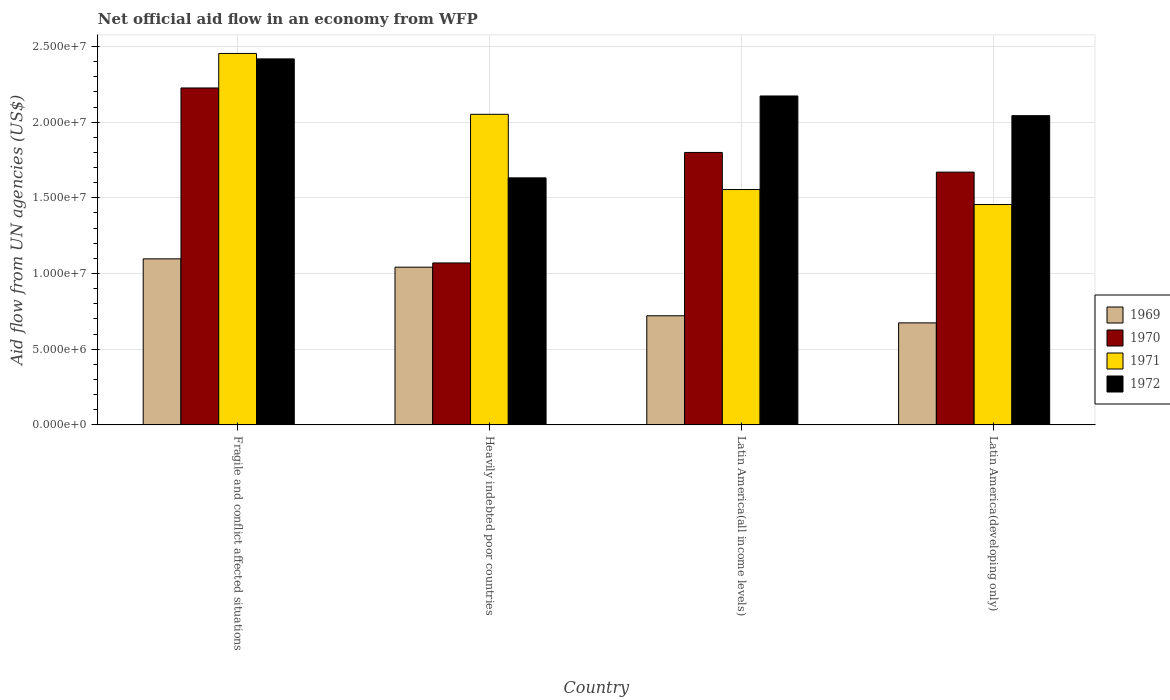How many groups of bars are there?
Keep it short and to the point. 4. How many bars are there on the 2nd tick from the left?
Your response must be concise. 4. How many bars are there on the 3rd tick from the right?
Provide a short and direct response. 4. What is the label of the 3rd group of bars from the left?
Give a very brief answer. Latin America(all income levels). What is the net official aid flow in 1969 in Latin America(all income levels)?
Make the answer very short. 7.21e+06. Across all countries, what is the maximum net official aid flow in 1972?
Provide a succinct answer. 2.42e+07. Across all countries, what is the minimum net official aid flow in 1969?
Keep it short and to the point. 6.74e+06. In which country was the net official aid flow in 1972 maximum?
Keep it short and to the point. Fragile and conflict affected situations. In which country was the net official aid flow in 1971 minimum?
Your answer should be very brief. Latin America(developing only). What is the total net official aid flow in 1972 in the graph?
Keep it short and to the point. 8.27e+07. What is the difference between the net official aid flow in 1969 in Latin America(developing only) and the net official aid flow in 1972 in Heavily indebted poor countries?
Provide a short and direct response. -9.58e+06. What is the average net official aid flow in 1971 per country?
Provide a succinct answer. 1.88e+07. What is the difference between the net official aid flow of/in 1970 and net official aid flow of/in 1971 in Latin America(all income levels)?
Your response must be concise. 2.45e+06. What is the ratio of the net official aid flow in 1969 in Heavily indebted poor countries to that in Latin America(developing only)?
Your response must be concise. 1.55. Is the net official aid flow in 1970 in Heavily indebted poor countries less than that in Latin America(developing only)?
Make the answer very short. Yes. What is the difference between the highest and the second highest net official aid flow in 1972?
Offer a very short reply. 3.75e+06. What is the difference between the highest and the lowest net official aid flow in 1970?
Provide a succinct answer. 1.16e+07. Is it the case that in every country, the sum of the net official aid flow in 1969 and net official aid flow in 1972 is greater than the sum of net official aid flow in 1971 and net official aid flow in 1970?
Keep it short and to the point. No. Is it the case that in every country, the sum of the net official aid flow in 1969 and net official aid flow in 1971 is greater than the net official aid flow in 1972?
Your response must be concise. Yes. How many bars are there?
Ensure brevity in your answer.  16. Are all the bars in the graph horizontal?
Offer a terse response. No. How many countries are there in the graph?
Your answer should be compact. 4. Are the values on the major ticks of Y-axis written in scientific E-notation?
Your answer should be very brief. Yes. Does the graph contain grids?
Your answer should be very brief. Yes. How are the legend labels stacked?
Provide a short and direct response. Vertical. What is the title of the graph?
Offer a terse response. Net official aid flow in an economy from WFP. Does "1972" appear as one of the legend labels in the graph?
Provide a short and direct response. Yes. What is the label or title of the Y-axis?
Offer a terse response. Aid flow from UN agencies (US$). What is the Aid flow from UN agencies (US$) in 1969 in Fragile and conflict affected situations?
Your answer should be very brief. 1.10e+07. What is the Aid flow from UN agencies (US$) of 1970 in Fragile and conflict affected situations?
Make the answer very short. 2.23e+07. What is the Aid flow from UN agencies (US$) in 1971 in Fragile and conflict affected situations?
Give a very brief answer. 2.45e+07. What is the Aid flow from UN agencies (US$) of 1972 in Fragile and conflict affected situations?
Your answer should be compact. 2.42e+07. What is the Aid flow from UN agencies (US$) of 1969 in Heavily indebted poor countries?
Keep it short and to the point. 1.04e+07. What is the Aid flow from UN agencies (US$) in 1970 in Heavily indebted poor countries?
Make the answer very short. 1.07e+07. What is the Aid flow from UN agencies (US$) of 1971 in Heavily indebted poor countries?
Offer a terse response. 2.05e+07. What is the Aid flow from UN agencies (US$) of 1972 in Heavily indebted poor countries?
Your response must be concise. 1.63e+07. What is the Aid flow from UN agencies (US$) of 1969 in Latin America(all income levels)?
Give a very brief answer. 7.21e+06. What is the Aid flow from UN agencies (US$) in 1970 in Latin America(all income levels)?
Offer a terse response. 1.80e+07. What is the Aid flow from UN agencies (US$) of 1971 in Latin America(all income levels)?
Make the answer very short. 1.56e+07. What is the Aid flow from UN agencies (US$) of 1972 in Latin America(all income levels)?
Your answer should be compact. 2.17e+07. What is the Aid flow from UN agencies (US$) of 1969 in Latin America(developing only)?
Your response must be concise. 6.74e+06. What is the Aid flow from UN agencies (US$) in 1970 in Latin America(developing only)?
Your answer should be compact. 1.67e+07. What is the Aid flow from UN agencies (US$) of 1971 in Latin America(developing only)?
Keep it short and to the point. 1.46e+07. What is the Aid flow from UN agencies (US$) in 1972 in Latin America(developing only)?
Your response must be concise. 2.04e+07. Across all countries, what is the maximum Aid flow from UN agencies (US$) of 1969?
Provide a succinct answer. 1.10e+07. Across all countries, what is the maximum Aid flow from UN agencies (US$) of 1970?
Keep it short and to the point. 2.23e+07. Across all countries, what is the maximum Aid flow from UN agencies (US$) of 1971?
Give a very brief answer. 2.45e+07. Across all countries, what is the maximum Aid flow from UN agencies (US$) of 1972?
Provide a succinct answer. 2.42e+07. Across all countries, what is the minimum Aid flow from UN agencies (US$) in 1969?
Ensure brevity in your answer.  6.74e+06. Across all countries, what is the minimum Aid flow from UN agencies (US$) in 1970?
Give a very brief answer. 1.07e+07. Across all countries, what is the minimum Aid flow from UN agencies (US$) of 1971?
Keep it short and to the point. 1.46e+07. Across all countries, what is the minimum Aid flow from UN agencies (US$) in 1972?
Provide a succinct answer. 1.63e+07. What is the total Aid flow from UN agencies (US$) in 1969 in the graph?
Keep it short and to the point. 3.53e+07. What is the total Aid flow from UN agencies (US$) in 1970 in the graph?
Give a very brief answer. 6.77e+07. What is the total Aid flow from UN agencies (US$) of 1971 in the graph?
Give a very brief answer. 7.52e+07. What is the total Aid flow from UN agencies (US$) in 1972 in the graph?
Your answer should be very brief. 8.27e+07. What is the difference between the Aid flow from UN agencies (US$) of 1970 in Fragile and conflict affected situations and that in Heavily indebted poor countries?
Ensure brevity in your answer.  1.16e+07. What is the difference between the Aid flow from UN agencies (US$) of 1971 in Fragile and conflict affected situations and that in Heavily indebted poor countries?
Provide a succinct answer. 4.02e+06. What is the difference between the Aid flow from UN agencies (US$) in 1972 in Fragile and conflict affected situations and that in Heavily indebted poor countries?
Your response must be concise. 7.86e+06. What is the difference between the Aid flow from UN agencies (US$) in 1969 in Fragile and conflict affected situations and that in Latin America(all income levels)?
Your answer should be compact. 3.76e+06. What is the difference between the Aid flow from UN agencies (US$) in 1970 in Fragile and conflict affected situations and that in Latin America(all income levels)?
Provide a succinct answer. 4.26e+06. What is the difference between the Aid flow from UN agencies (US$) of 1971 in Fragile and conflict affected situations and that in Latin America(all income levels)?
Your answer should be very brief. 8.99e+06. What is the difference between the Aid flow from UN agencies (US$) of 1972 in Fragile and conflict affected situations and that in Latin America(all income levels)?
Ensure brevity in your answer.  2.45e+06. What is the difference between the Aid flow from UN agencies (US$) of 1969 in Fragile and conflict affected situations and that in Latin America(developing only)?
Provide a short and direct response. 4.23e+06. What is the difference between the Aid flow from UN agencies (US$) in 1970 in Fragile and conflict affected situations and that in Latin America(developing only)?
Your answer should be compact. 5.56e+06. What is the difference between the Aid flow from UN agencies (US$) in 1971 in Fragile and conflict affected situations and that in Latin America(developing only)?
Make the answer very short. 9.98e+06. What is the difference between the Aid flow from UN agencies (US$) of 1972 in Fragile and conflict affected situations and that in Latin America(developing only)?
Your response must be concise. 3.75e+06. What is the difference between the Aid flow from UN agencies (US$) in 1969 in Heavily indebted poor countries and that in Latin America(all income levels)?
Ensure brevity in your answer.  3.21e+06. What is the difference between the Aid flow from UN agencies (US$) in 1970 in Heavily indebted poor countries and that in Latin America(all income levels)?
Your answer should be compact. -7.30e+06. What is the difference between the Aid flow from UN agencies (US$) in 1971 in Heavily indebted poor countries and that in Latin America(all income levels)?
Provide a succinct answer. 4.97e+06. What is the difference between the Aid flow from UN agencies (US$) of 1972 in Heavily indebted poor countries and that in Latin America(all income levels)?
Offer a terse response. -5.41e+06. What is the difference between the Aid flow from UN agencies (US$) of 1969 in Heavily indebted poor countries and that in Latin America(developing only)?
Provide a short and direct response. 3.68e+06. What is the difference between the Aid flow from UN agencies (US$) of 1970 in Heavily indebted poor countries and that in Latin America(developing only)?
Ensure brevity in your answer.  -6.00e+06. What is the difference between the Aid flow from UN agencies (US$) of 1971 in Heavily indebted poor countries and that in Latin America(developing only)?
Ensure brevity in your answer.  5.96e+06. What is the difference between the Aid flow from UN agencies (US$) in 1972 in Heavily indebted poor countries and that in Latin America(developing only)?
Offer a very short reply. -4.11e+06. What is the difference between the Aid flow from UN agencies (US$) of 1970 in Latin America(all income levels) and that in Latin America(developing only)?
Give a very brief answer. 1.30e+06. What is the difference between the Aid flow from UN agencies (US$) in 1971 in Latin America(all income levels) and that in Latin America(developing only)?
Your answer should be compact. 9.90e+05. What is the difference between the Aid flow from UN agencies (US$) in 1972 in Latin America(all income levels) and that in Latin America(developing only)?
Give a very brief answer. 1.30e+06. What is the difference between the Aid flow from UN agencies (US$) of 1969 in Fragile and conflict affected situations and the Aid flow from UN agencies (US$) of 1971 in Heavily indebted poor countries?
Give a very brief answer. -9.55e+06. What is the difference between the Aid flow from UN agencies (US$) of 1969 in Fragile and conflict affected situations and the Aid flow from UN agencies (US$) of 1972 in Heavily indebted poor countries?
Keep it short and to the point. -5.35e+06. What is the difference between the Aid flow from UN agencies (US$) of 1970 in Fragile and conflict affected situations and the Aid flow from UN agencies (US$) of 1971 in Heavily indebted poor countries?
Ensure brevity in your answer.  1.74e+06. What is the difference between the Aid flow from UN agencies (US$) of 1970 in Fragile and conflict affected situations and the Aid flow from UN agencies (US$) of 1972 in Heavily indebted poor countries?
Provide a short and direct response. 5.94e+06. What is the difference between the Aid flow from UN agencies (US$) of 1971 in Fragile and conflict affected situations and the Aid flow from UN agencies (US$) of 1972 in Heavily indebted poor countries?
Your answer should be compact. 8.22e+06. What is the difference between the Aid flow from UN agencies (US$) of 1969 in Fragile and conflict affected situations and the Aid flow from UN agencies (US$) of 1970 in Latin America(all income levels)?
Provide a succinct answer. -7.03e+06. What is the difference between the Aid flow from UN agencies (US$) in 1969 in Fragile and conflict affected situations and the Aid flow from UN agencies (US$) in 1971 in Latin America(all income levels)?
Your response must be concise. -4.58e+06. What is the difference between the Aid flow from UN agencies (US$) of 1969 in Fragile and conflict affected situations and the Aid flow from UN agencies (US$) of 1972 in Latin America(all income levels)?
Give a very brief answer. -1.08e+07. What is the difference between the Aid flow from UN agencies (US$) of 1970 in Fragile and conflict affected situations and the Aid flow from UN agencies (US$) of 1971 in Latin America(all income levels)?
Your answer should be compact. 6.71e+06. What is the difference between the Aid flow from UN agencies (US$) of 1970 in Fragile and conflict affected situations and the Aid flow from UN agencies (US$) of 1972 in Latin America(all income levels)?
Provide a short and direct response. 5.30e+05. What is the difference between the Aid flow from UN agencies (US$) of 1971 in Fragile and conflict affected situations and the Aid flow from UN agencies (US$) of 1972 in Latin America(all income levels)?
Provide a succinct answer. 2.81e+06. What is the difference between the Aid flow from UN agencies (US$) of 1969 in Fragile and conflict affected situations and the Aid flow from UN agencies (US$) of 1970 in Latin America(developing only)?
Provide a short and direct response. -5.73e+06. What is the difference between the Aid flow from UN agencies (US$) in 1969 in Fragile and conflict affected situations and the Aid flow from UN agencies (US$) in 1971 in Latin America(developing only)?
Give a very brief answer. -3.59e+06. What is the difference between the Aid flow from UN agencies (US$) of 1969 in Fragile and conflict affected situations and the Aid flow from UN agencies (US$) of 1972 in Latin America(developing only)?
Keep it short and to the point. -9.46e+06. What is the difference between the Aid flow from UN agencies (US$) of 1970 in Fragile and conflict affected situations and the Aid flow from UN agencies (US$) of 1971 in Latin America(developing only)?
Provide a succinct answer. 7.70e+06. What is the difference between the Aid flow from UN agencies (US$) in 1970 in Fragile and conflict affected situations and the Aid flow from UN agencies (US$) in 1972 in Latin America(developing only)?
Offer a terse response. 1.83e+06. What is the difference between the Aid flow from UN agencies (US$) in 1971 in Fragile and conflict affected situations and the Aid flow from UN agencies (US$) in 1972 in Latin America(developing only)?
Provide a succinct answer. 4.11e+06. What is the difference between the Aid flow from UN agencies (US$) in 1969 in Heavily indebted poor countries and the Aid flow from UN agencies (US$) in 1970 in Latin America(all income levels)?
Provide a succinct answer. -7.58e+06. What is the difference between the Aid flow from UN agencies (US$) of 1969 in Heavily indebted poor countries and the Aid flow from UN agencies (US$) of 1971 in Latin America(all income levels)?
Your response must be concise. -5.13e+06. What is the difference between the Aid flow from UN agencies (US$) of 1969 in Heavily indebted poor countries and the Aid flow from UN agencies (US$) of 1972 in Latin America(all income levels)?
Your response must be concise. -1.13e+07. What is the difference between the Aid flow from UN agencies (US$) in 1970 in Heavily indebted poor countries and the Aid flow from UN agencies (US$) in 1971 in Latin America(all income levels)?
Your answer should be compact. -4.85e+06. What is the difference between the Aid flow from UN agencies (US$) in 1970 in Heavily indebted poor countries and the Aid flow from UN agencies (US$) in 1972 in Latin America(all income levels)?
Your response must be concise. -1.10e+07. What is the difference between the Aid flow from UN agencies (US$) of 1971 in Heavily indebted poor countries and the Aid flow from UN agencies (US$) of 1972 in Latin America(all income levels)?
Your answer should be very brief. -1.21e+06. What is the difference between the Aid flow from UN agencies (US$) of 1969 in Heavily indebted poor countries and the Aid flow from UN agencies (US$) of 1970 in Latin America(developing only)?
Your answer should be very brief. -6.28e+06. What is the difference between the Aid flow from UN agencies (US$) in 1969 in Heavily indebted poor countries and the Aid flow from UN agencies (US$) in 1971 in Latin America(developing only)?
Provide a succinct answer. -4.14e+06. What is the difference between the Aid flow from UN agencies (US$) in 1969 in Heavily indebted poor countries and the Aid flow from UN agencies (US$) in 1972 in Latin America(developing only)?
Provide a succinct answer. -1.00e+07. What is the difference between the Aid flow from UN agencies (US$) of 1970 in Heavily indebted poor countries and the Aid flow from UN agencies (US$) of 1971 in Latin America(developing only)?
Offer a very short reply. -3.86e+06. What is the difference between the Aid flow from UN agencies (US$) in 1970 in Heavily indebted poor countries and the Aid flow from UN agencies (US$) in 1972 in Latin America(developing only)?
Give a very brief answer. -9.73e+06. What is the difference between the Aid flow from UN agencies (US$) in 1969 in Latin America(all income levels) and the Aid flow from UN agencies (US$) in 1970 in Latin America(developing only)?
Your answer should be very brief. -9.49e+06. What is the difference between the Aid flow from UN agencies (US$) of 1969 in Latin America(all income levels) and the Aid flow from UN agencies (US$) of 1971 in Latin America(developing only)?
Your answer should be very brief. -7.35e+06. What is the difference between the Aid flow from UN agencies (US$) of 1969 in Latin America(all income levels) and the Aid flow from UN agencies (US$) of 1972 in Latin America(developing only)?
Offer a terse response. -1.32e+07. What is the difference between the Aid flow from UN agencies (US$) in 1970 in Latin America(all income levels) and the Aid flow from UN agencies (US$) in 1971 in Latin America(developing only)?
Your answer should be compact. 3.44e+06. What is the difference between the Aid flow from UN agencies (US$) of 1970 in Latin America(all income levels) and the Aid flow from UN agencies (US$) of 1972 in Latin America(developing only)?
Provide a succinct answer. -2.43e+06. What is the difference between the Aid flow from UN agencies (US$) in 1971 in Latin America(all income levels) and the Aid flow from UN agencies (US$) in 1972 in Latin America(developing only)?
Give a very brief answer. -4.88e+06. What is the average Aid flow from UN agencies (US$) of 1969 per country?
Your answer should be very brief. 8.84e+06. What is the average Aid flow from UN agencies (US$) of 1970 per country?
Your answer should be very brief. 1.69e+07. What is the average Aid flow from UN agencies (US$) in 1971 per country?
Offer a very short reply. 1.88e+07. What is the average Aid flow from UN agencies (US$) of 1972 per country?
Keep it short and to the point. 2.07e+07. What is the difference between the Aid flow from UN agencies (US$) in 1969 and Aid flow from UN agencies (US$) in 1970 in Fragile and conflict affected situations?
Your answer should be compact. -1.13e+07. What is the difference between the Aid flow from UN agencies (US$) of 1969 and Aid flow from UN agencies (US$) of 1971 in Fragile and conflict affected situations?
Provide a succinct answer. -1.36e+07. What is the difference between the Aid flow from UN agencies (US$) in 1969 and Aid flow from UN agencies (US$) in 1972 in Fragile and conflict affected situations?
Provide a short and direct response. -1.32e+07. What is the difference between the Aid flow from UN agencies (US$) in 1970 and Aid flow from UN agencies (US$) in 1971 in Fragile and conflict affected situations?
Make the answer very short. -2.28e+06. What is the difference between the Aid flow from UN agencies (US$) of 1970 and Aid flow from UN agencies (US$) of 1972 in Fragile and conflict affected situations?
Give a very brief answer. -1.92e+06. What is the difference between the Aid flow from UN agencies (US$) of 1969 and Aid flow from UN agencies (US$) of 1970 in Heavily indebted poor countries?
Ensure brevity in your answer.  -2.80e+05. What is the difference between the Aid flow from UN agencies (US$) of 1969 and Aid flow from UN agencies (US$) of 1971 in Heavily indebted poor countries?
Your response must be concise. -1.01e+07. What is the difference between the Aid flow from UN agencies (US$) of 1969 and Aid flow from UN agencies (US$) of 1972 in Heavily indebted poor countries?
Provide a succinct answer. -5.90e+06. What is the difference between the Aid flow from UN agencies (US$) of 1970 and Aid flow from UN agencies (US$) of 1971 in Heavily indebted poor countries?
Make the answer very short. -9.82e+06. What is the difference between the Aid flow from UN agencies (US$) in 1970 and Aid flow from UN agencies (US$) in 1972 in Heavily indebted poor countries?
Your answer should be compact. -5.62e+06. What is the difference between the Aid flow from UN agencies (US$) of 1971 and Aid flow from UN agencies (US$) of 1972 in Heavily indebted poor countries?
Your response must be concise. 4.20e+06. What is the difference between the Aid flow from UN agencies (US$) of 1969 and Aid flow from UN agencies (US$) of 1970 in Latin America(all income levels)?
Keep it short and to the point. -1.08e+07. What is the difference between the Aid flow from UN agencies (US$) in 1969 and Aid flow from UN agencies (US$) in 1971 in Latin America(all income levels)?
Offer a very short reply. -8.34e+06. What is the difference between the Aid flow from UN agencies (US$) of 1969 and Aid flow from UN agencies (US$) of 1972 in Latin America(all income levels)?
Offer a very short reply. -1.45e+07. What is the difference between the Aid flow from UN agencies (US$) in 1970 and Aid flow from UN agencies (US$) in 1971 in Latin America(all income levels)?
Ensure brevity in your answer.  2.45e+06. What is the difference between the Aid flow from UN agencies (US$) of 1970 and Aid flow from UN agencies (US$) of 1972 in Latin America(all income levels)?
Make the answer very short. -3.73e+06. What is the difference between the Aid flow from UN agencies (US$) in 1971 and Aid flow from UN agencies (US$) in 1972 in Latin America(all income levels)?
Your response must be concise. -6.18e+06. What is the difference between the Aid flow from UN agencies (US$) of 1969 and Aid flow from UN agencies (US$) of 1970 in Latin America(developing only)?
Make the answer very short. -9.96e+06. What is the difference between the Aid flow from UN agencies (US$) in 1969 and Aid flow from UN agencies (US$) in 1971 in Latin America(developing only)?
Provide a succinct answer. -7.82e+06. What is the difference between the Aid flow from UN agencies (US$) in 1969 and Aid flow from UN agencies (US$) in 1972 in Latin America(developing only)?
Ensure brevity in your answer.  -1.37e+07. What is the difference between the Aid flow from UN agencies (US$) of 1970 and Aid flow from UN agencies (US$) of 1971 in Latin America(developing only)?
Offer a terse response. 2.14e+06. What is the difference between the Aid flow from UN agencies (US$) in 1970 and Aid flow from UN agencies (US$) in 1972 in Latin America(developing only)?
Your answer should be very brief. -3.73e+06. What is the difference between the Aid flow from UN agencies (US$) of 1971 and Aid flow from UN agencies (US$) of 1972 in Latin America(developing only)?
Keep it short and to the point. -5.87e+06. What is the ratio of the Aid flow from UN agencies (US$) in 1969 in Fragile and conflict affected situations to that in Heavily indebted poor countries?
Keep it short and to the point. 1.05. What is the ratio of the Aid flow from UN agencies (US$) of 1970 in Fragile and conflict affected situations to that in Heavily indebted poor countries?
Ensure brevity in your answer.  2.08. What is the ratio of the Aid flow from UN agencies (US$) in 1971 in Fragile and conflict affected situations to that in Heavily indebted poor countries?
Your answer should be very brief. 1.2. What is the ratio of the Aid flow from UN agencies (US$) in 1972 in Fragile and conflict affected situations to that in Heavily indebted poor countries?
Your answer should be compact. 1.48. What is the ratio of the Aid flow from UN agencies (US$) of 1969 in Fragile and conflict affected situations to that in Latin America(all income levels)?
Ensure brevity in your answer.  1.52. What is the ratio of the Aid flow from UN agencies (US$) of 1970 in Fragile and conflict affected situations to that in Latin America(all income levels)?
Give a very brief answer. 1.24. What is the ratio of the Aid flow from UN agencies (US$) in 1971 in Fragile and conflict affected situations to that in Latin America(all income levels)?
Keep it short and to the point. 1.58. What is the ratio of the Aid flow from UN agencies (US$) of 1972 in Fragile and conflict affected situations to that in Latin America(all income levels)?
Provide a short and direct response. 1.11. What is the ratio of the Aid flow from UN agencies (US$) of 1969 in Fragile and conflict affected situations to that in Latin America(developing only)?
Keep it short and to the point. 1.63. What is the ratio of the Aid flow from UN agencies (US$) of 1970 in Fragile and conflict affected situations to that in Latin America(developing only)?
Offer a very short reply. 1.33. What is the ratio of the Aid flow from UN agencies (US$) of 1971 in Fragile and conflict affected situations to that in Latin America(developing only)?
Your answer should be very brief. 1.69. What is the ratio of the Aid flow from UN agencies (US$) in 1972 in Fragile and conflict affected situations to that in Latin America(developing only)?
Provide a short and direct response. 1.18. What is the ratio of the Aid flow from UN agencies (US$) of 1969 in Heavily indebted poor countries to that in Latin America(all income levels)?
Make the answer very short. 1.45. What is the ratio of the Aid flow from UN agencies (US$) of 1970 in Heavily indebted poor countries to that in Latin America(all income levels)?
Ensure brevity in your answer.  0.59. What is the ratio of the Aid flow from UN agencies (US$) of 1971 in Heavily indebted poor countries to that in Latin America(all income levels)?
Provide a short and direct response. 1.32. What is the ratio of the Aid flow from UN agencies (US$) in 1972 in Heavily indebted poor countries to that in Latin America(all income levels)?
Offer a terse response. 0.75. What is the ratio of the Aid flow from UN agencies (US$) of 1969 in Heavily indebted poor countries to that in Latin America(developing only)?
Your answer should be very brief. 1.55. What is the ratio of the Aid flow from UN agencies (US$) of 1970 in Heavily indebted poor countries to that in Latin America(developing only)?
Your answer should be very brief. 0.64. What is the ratio of the Aid flow from UN agencies (US$) of 1971 in Heavily indebted poor countries to that in Latin America(developing only)?
Ensure brevity in your answer.  1.41. What is the ratio of the Aid flow from UN agencies (US$) in 1972 in Heavily indebted poor countries to that in Latin America(developing only)?
Give a very brief answer. 0.8. What is the ratio of the Aid flow from UN agencies (US$) in 1969 in Latin America(all income levels) to that in Latin America(developing only)?
Ensure brevity in your answer.  1.07. What is the ratio of the Aid flow from UN agencies (US$) in 1970 in Latin America(all income levels) to that in Latin America(developing only)?
Make the answer very short. 1.08. What is the ratio of the Aid flow from UN agencies (US$) in 1971 in Latin America(all income levels) to that in Latin America(developing only)?
Give a very brief answer. 1.07. What is the ratio of the Aid flow from UN agencies (US$) of 1972 in Latin America(all income levels) to that in Latin America(developing only)?
Offer a terse response. 1.06. What is the difference between the highest and the second highest Aid flow from UN agencies (US$) of 1970?
Your answer should be very brief. 4.26e+06. What is the difference between the highest and the second highest Aid flow from UN agencies (US$) of 1971?
Make the answer very short. 4.02e+06. What is the difference between the highest and the second highest Aid flow from UN agencies (US$) of 1972?
Offer a very short reply. 2.45e+06. What is the difference between the highest and the lowest Aid flow from UN agencies (US$) of 1969?
Keep it short and to the point. 4.23e+06. What is the difference between the highest and the lowest Aid flow from UN agencies (US$) in 1970?
Provide a short and direct response. 1.16e+07. What is the difference between the highest and the lowest Aid flow from UN agencies (US$) of 1971?
Keep it short and to the point. 9.98e+06. What is the difference between the highest and the lowest Aid flow from UN agencies (US$) of 1972?
Provide a short and direct response. 7.86e+06. 